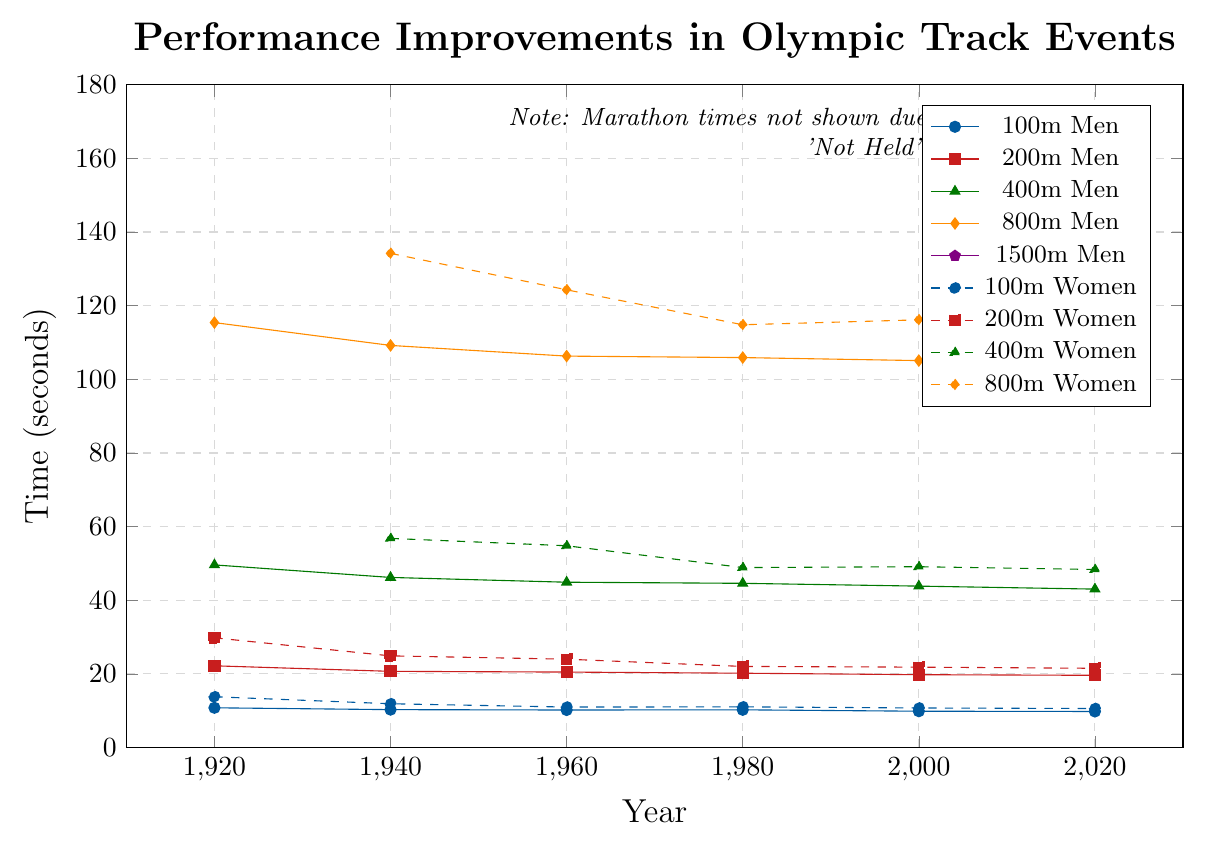What event has the smallest improvement in times between 1920 and 2020? Look at the differences in times recorded in 1920 and 2020 for each event. The 100m Men's event went from 10.8 seconds in 1920 to 9.80 seconds in 2020, a difference of 1.00 seconds. Repeat this for each event and identify which has the smallest difference.
Answer: 100m Men Which women's event saw the most significant improvement in times? Compare the improvements of all the women's events by looking at the differences in recorded times between the earliest and latest available data points. For example, the 100m Women improved from 13.8 seconds in 1920 to 10.61 seconds in 2020, a difference of 3.19 seconds. Repeat this for each event and identify the largest improvement.
Answer: 200m Women What is the average time improvement per decade for the 200m Men's event between 1920 and 2020? Calculate the total improvement in seconds from 1920 to 2020 for the 200m Men: 22.2 seconds in 1920 to 19.62 seconds in 2020, a difference of 2.58 seconds. Since there are 10 decades between 1920 and 2020, divide the total improvement by the number of decades.
Answer: 0.258 seconds per decade Which men's event had the largest decrease in time between 1920 and 1960? Examine the difference in times from 1920 to 1960 for each men's event. For example, the 100m Men went from 10.8 seconds in 1920 to 10.2 seconds in 1960, a difference of 0.6 seconds. Repeat this for each event and identify the event with the largest time decrease.
Answer: 1500m Men Which event had the least significant improvement since 2000? Compare the differences in times for each event from 2000 to 2020. For example, the 100m Men went from 9.87 seconds in 2000 to 9.80 seconds in 2020, a difference of 0.07 seconds. Repeat this for each event and identify which had the smallest difference.
Answer: 400m Women What are the two closest data points in terms of time improvement for the Men's 400m event between any consecutive years? Look at the times for the Men's 400m event across all the years and identify the two closest data points in terms of time difference from one year to the next. For instance, between 1960 (44.9 seconds) and 1980 (44.60 seconds), the difference is 0.30 seconds.
Answer: 1960-1980 How did the time improvement for the Women's 800m event from 1940 to 2020 compare to the Men's 800m event for the same period? Calculate the difference in recorded times for both the Women's and Men's 800m events for the years 1940 to 2020. Women's times improved from 134.2 seconds in 1940 to 113.43 seconds in 2020, a difference of 20.77 seconds. Men's times improved from 109.2 seconds to 103.76 seconds in the same period, a difference of 5.44 seconds. Then, compare these improvements.
Answer: Women's 800m Which event has the largest variance in performance improvement among the data points provided? Calculate the variance for each event's times. Variance measures the spread between numbers in a data set. Look at each event's time data points and determine which one has the highest variance using the standard deviation formula.
Answer: Marathon Men 